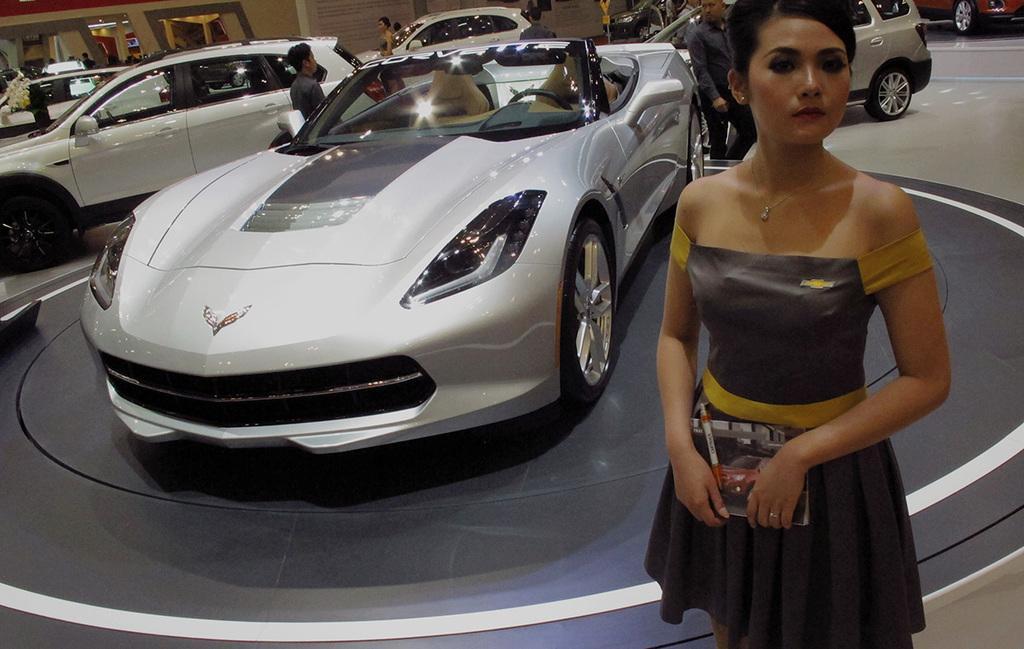Please provide a concise description of this image. In this picture we can see a group of vehicles,people on the ground and in the background we can see a wall. 